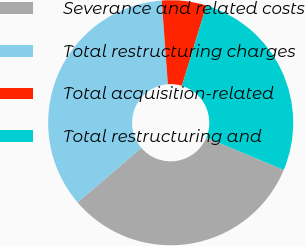Convert chart. <chart><loc_0><loc_0><loc_500><loc_500><pie_chart><fcel>Severance and related costs<fcel>Total restructuring charges<fcel>Total acquisition-related<fcel>Total restructuring and<nl><fcel>32.45%<fcel>35.11%<fcel>5.87%<fcel>26.58%<nl></chart> 